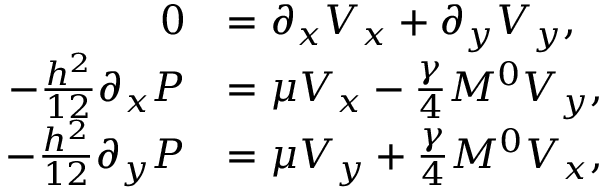Convert formula to latex. <formula><loc_0><loc_0><loc_500><loc_500>\begin{array} { r l } { 0 } & { = \partial _ { x } V _ { x } + \partial _ { y } V _ { y } , } \\ { - \frac { h ^ { 2 } } { 1 2 } \partial _ { x } P } & { = \mu V _ { x } - \frac { \gamma } { 4 } M ^ { 0 } V _ { y } , } \\ { - \frac { h ^ { 2 } } { 1 2 } \partial _ { y } P } & { = \mu V _ { y } + \frac { \gamma } { 4 } M ^ { 0 } V _ { x } , } \end{array}</formula> 